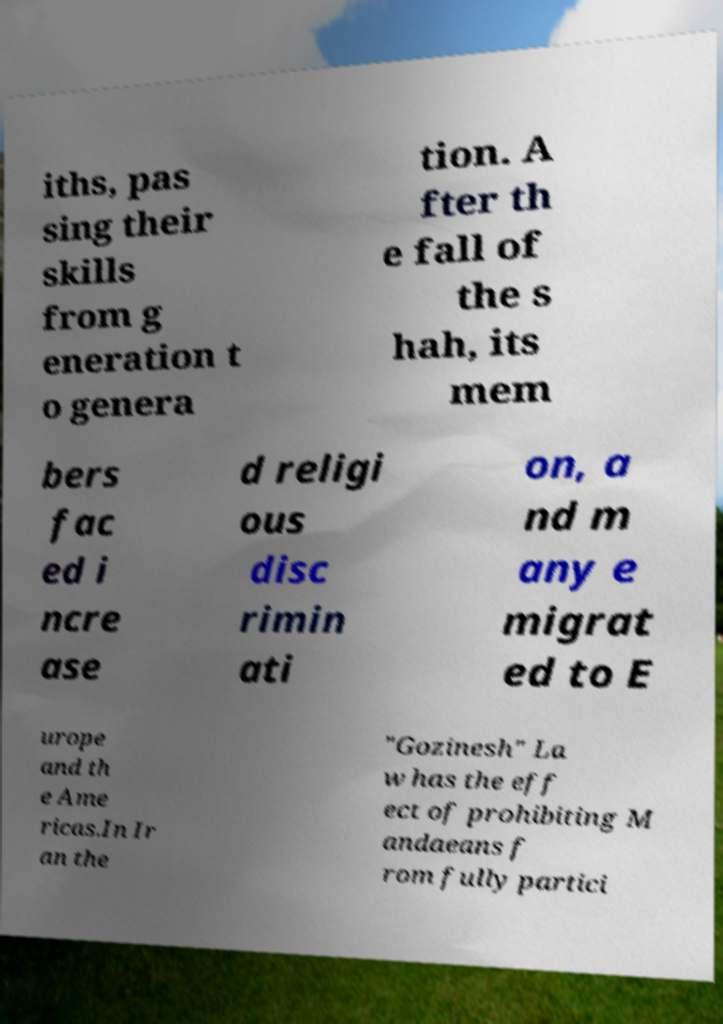There's text embedded in this image that I need extracted. Can you transcribe it verbatim? iths, pas sing their skills from g eneration t o genera tion. A fter th e fall of the s hah, its mem bers fac ed i ncre ase d religi ous disc rimin ati on, a nd m any e migrat ed to E urope and th e Ame ricas.In Ir an the "Gozinesh" La w has the eff ect of prohibiting M andaeans f rom fully partici 